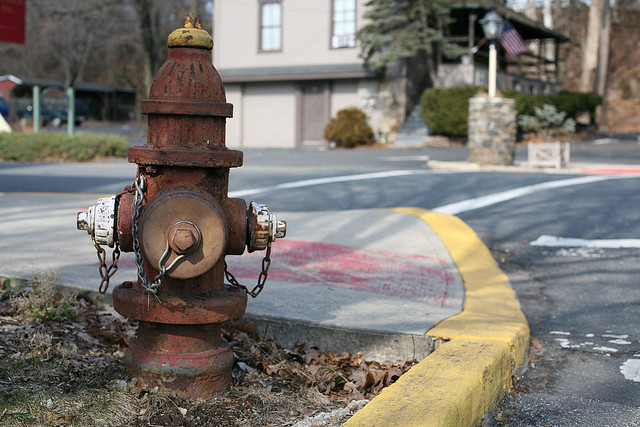<image>What kind of flag is there? There might be an American flag, but it's not clearly confirmed. What kind of flag is there? I don't know what kind of flag is there. It can be 'american', 'red white and blue', 'us flag', 'red', or something else. 